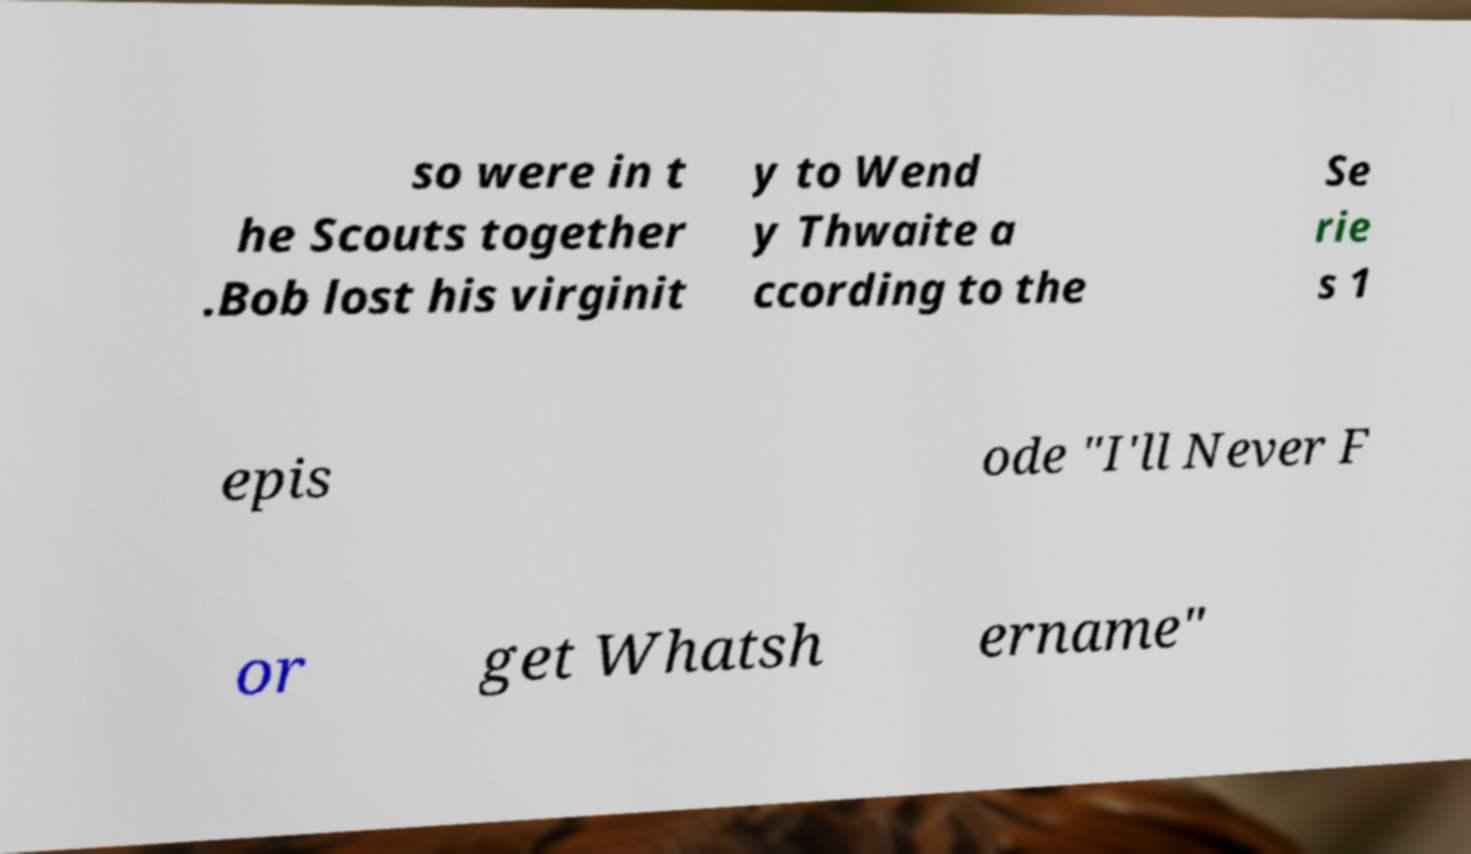There's text embedded in this image that I need extracted. Can you transcribe it verbatim? so were in t he Scouts together .Bob lost his virginit y to Wend y Thwaite a ccording to the Se rie s 1 epis ode "I'll Never F or get Whatsh ername" 